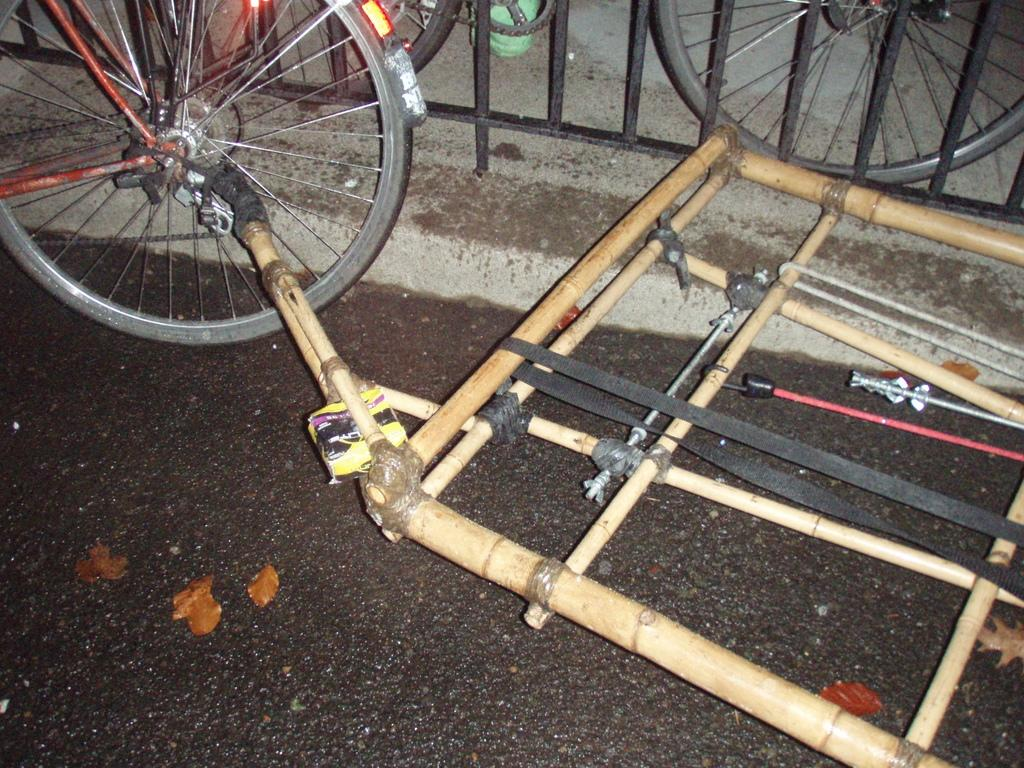What type of vehicles are in the image? There are bicycles in the image. What other object can be seen in the image besides the bicycles? There is a wooden object in the image. What type of architectural feature is present at the top of the image? There is railing at the top of the image. How many kittens can be seen playing with the bicycles in the image? There are no kittens present in the image. What type of natural disaster is occurring in the image? There is no indication of an earthquake or any other natural disaster in the image. 